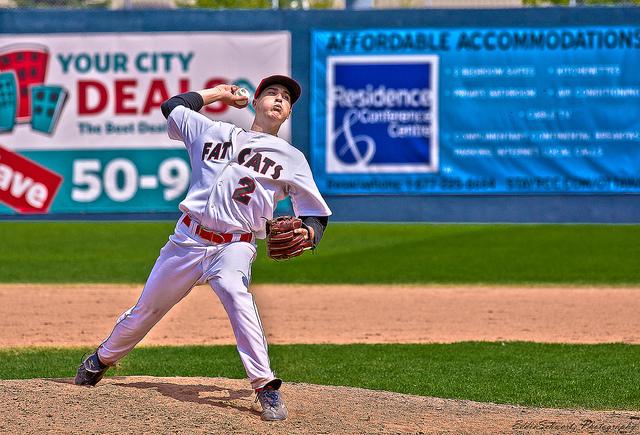What is this man about to do?
Be succinct. Pitch. What number is on the pitcher's jersey?
Answer briefly. 2. What is the name on the Jersey?
Answer briefly. Fat cats. What is the number on his jersey?
Write a very short answer. 2. Is the team on the field the Bears?
Concise answer only. No. 